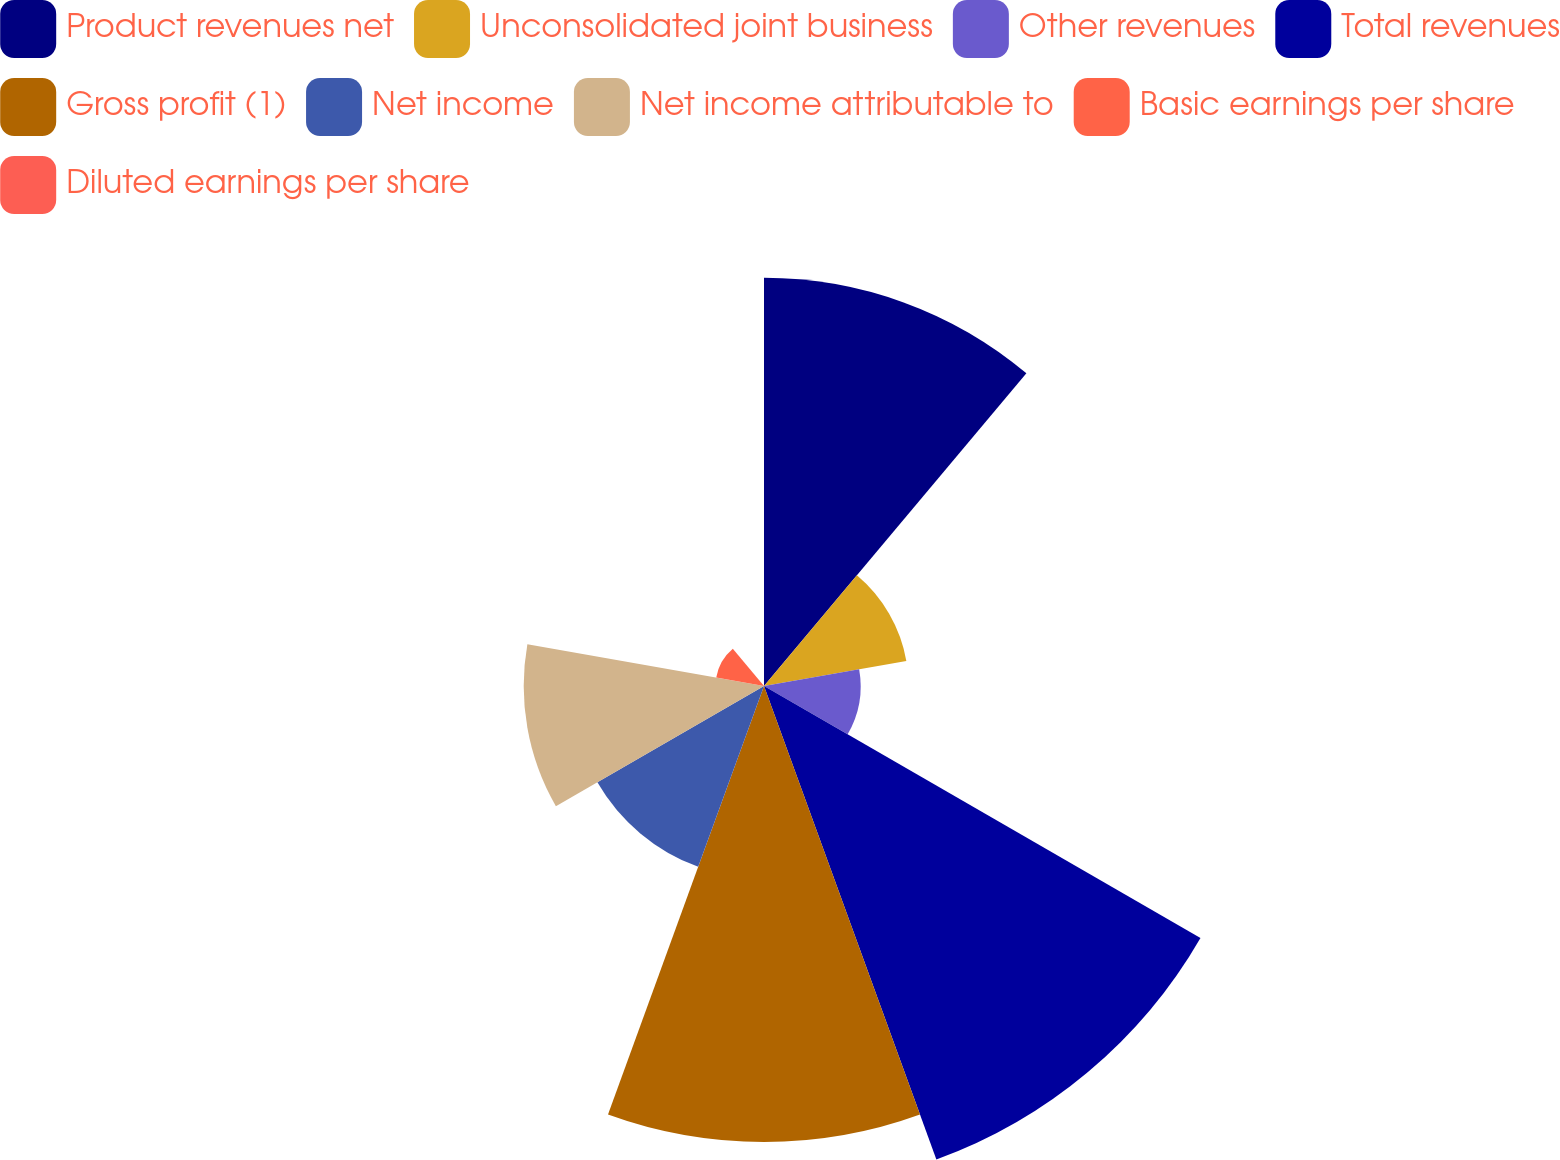Convert chart. <chart><loc_0><loc_0><loc_500><loc_500><pie_chart><fcel>Product revenues net<fcel>Unconsolidated joint business<fcel>Other revenues<fcel>Total revenues<fcel>Gross profit (1)<fcel>Net income<fcel>Net income attributable to<fcel>Basic earnings per share<fcel>Diluted earnings per share<nl><fcel>19.52%<fcel>6.91%<fcel>4.62%<fcel>24.1%<fcel>21.81%<fcel>9.2%<fcel>11.49%<fcel>2.32%<fcel>0.03%<nl></chart> 